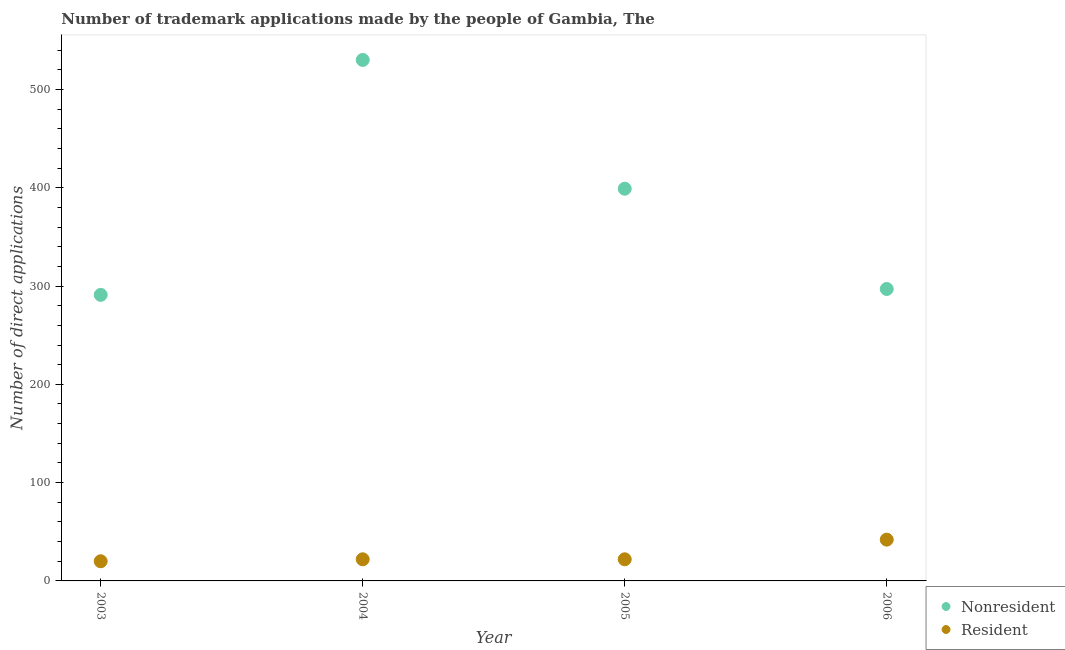How many different coloured dotlines are there?
Keep it short and to the point. 2. Is the number of dotlines equal to the number of legend labels?
Give a very brief answer. Yes. What is the number of trademark applications made by residents in 2006?
Provide a short and direct response. 42. Across all years, what is the maximum number of trademark applications made by non residents?
Give a very brief answer. 530. Across all years, what is the minimum number of trademark applications made by non residents?
Provide a short and direct response. 291. What is the total number of trademark applications made by non residents in the graph?
Offer a very short reply. 1517. What is the difference between the number of trademark applications made by non residents in 2004 and that in 2006?
Your answer should be compact. 233. What is the difference between the number of trademark applications made by residents in 2006 and the number of trademark applications made by non residents in 2004?
Give a very brief answer. -488. What is the average number of trademark applications made by non residents per year?
Give a very brief answer. 379.25. In the year 2004, what is the difference between the number of trademark applications made by non residents and number of trademark applications made by residents?
Your response must be concise. 508. What is the ratio of the number of trademark applications made by non residents in 2003 to that in 2004?
Your answer should be very brief. 0.55. Is the difference between the number of trademark applications made by residents in 2005 and 2006 greater than the difference between the number of trademark applications made by non residents in 2005 and 2006?
Keep it short and to the point. No. What is the difference between the highest and the lowest number of trademark applications made by residents?
Ensure brevity in your answer.  22. Does the number of trademark applications made by residents monotonically increase over the years?
Give a very brief answer. No. How many years are there in the graph?
Give a very brief answer. 4. What is the difference between two consecutive major ticks on the Y-axis?
Provide a succinct answer. 100. Where does the legend appear in the graph?
Provide a succinct answer. Bottom right. How are the legend labels stacked?
Your answer should be very brief. Vertical. What is the title of the graph?
Your response must be concise. Number of trademark applications made by the people of Gambia, The. Does "GDP at market prices" appear as one of the legend labels in the graph?
Your response must be concise. No. What is the label or title of the X-axis?
Your answer should be very brief. Year. What is the label or title of the Y-axis?
Your response must be concise. Number of direct applications. What is the Number of direct applications of Nonresident in 2003?
Your answer should be compact. 291. What is the Number of direct applications of Nonresident in 2004?
Your answer should be very brief. 530. What is the Number of direct applications of Resident in 2004?
Your answer should be compact. 22. What is the Number of direct applications of Nonresident in 2005?
Your response must be concise. 399. What is the Number of direct applications of Resident in 2005?
Offer a terse response. 22. What is the Number of direct applications in Nonresident in 2006?
Offer a terse response. 297. What is the Number of direct applications of Resident in 2006?
Your response must be concise. 42. Across all years, what is the maximum Number of direct applications in Nonresident?
Provide a succinct answer. 530. Across all years, what is the maximum Number of direct applications in Resident?
Ensure brevity in your answer.  42. Across all years, what is the minimum Number of direct applications in Nonresident?
Your response must be concise. 291. What is the total Number of direct applications in Nonresident in the graph?
Keep it short and to the point. 1517. What is the total Number of direct applications in Resident in the graph?
Offer a terse response. 106. What is the difference between the Number of direct applications in Nonresident in 2003 and that in 2004?
Ensure brevity in your answer.  -239. What is the difference between the Number of direct applications of Resident in 2003 and that in 2004?
Make the answer very short. -2. What is the difference between the Number of direct applications in Nonresident in 2003 and that in 2005?
Provide a short and direct response. -108. What is the difference between the Number of direct applications in Resident in 2003 and that in 2005?
Offer a very short reply. -2. What is the difference between the Number of direct applications in Nonresident in 2003 and that in 2006?
Offer a very short reply. -6. What is the difference between the Number of direct applications of Nonresident in 2004 and that in 2005?
Keep it short and to the point. 131. What is the difference between the Number of direct applications of Nonresident in 2004 and that in 2006?
Offer a terse response. 233. What is the difference between the Number of direct applications in Nonresident in 2005 and that in 2006?
Provide a short and direct response. 102. What is the difference between the Number of direct applications in Nonresident in 2003 and the Number of direct applications in Resident in 2004?
Your answer should be very brief. 269. What is the difference between the Number of direct applications in Nonresident in 2003 and the Number of direct applications in Resident in 2005?
Your answer should be very brief. 269. What is the difference between the Number of direct applications in Nonresident in 2003 and the Number of direct applications in Resident in 2006?
Offer a very short reply. 249. What is the difference between the Number of direct applications in Nonresident in 2004 and the Number of direct applications in Resident in 2005?
Give a very brief answer. 508. What is the difference between the Number of direct applications in Nonresident in 2004 and the Number of direct applications in Resident in 2006?
Give a very brief answer. 488. What is the difference between the Number of direct applications of Nonresident in 2005 and the Number of direct applications of Resident in 2006?
Your response must be concise. 357. What is the average Number of direct applications of Nonresident per year?
Your response must be concise. 379.25. In the year 2003, what is the difference between the Number of direct applications in Nonresident and Number of direct applications in Resident?
Offer a very short reply. 271. In the year 2004, what is the difference between the Number of direct applications of Nonresident and Number of direct applications of Resident?
Your answer should be compact. 508. In the year 2005, what is the difference between the Number of direct applications in Nonresident and Number of direct applications in Resident?
Keep it short and to the point. 377. In the year 2006, what is the difference between the Number of direct applications of Nonresident and Number of direct applications of Resident?
Your response must be concise. 255. What is the ratio of the Number of direct applications in Nonresident in 2003 to that in 2004?
Keep it short and to the point. 0.55. What is the ratio of the Number of direct applications in Nonresident in 2003 to that in 2005?
Keep it short and to the point. 0.73. What is the ratio of the Number of direct applications in Nonresident in 2003 to that in 2006?
Make the answer very short. 0.98. What is the ratio of the Number of direct applications of Resident in 2003 to that in 2006?
Your answer should be compact. 0.48. What is the ratio of the Number of direct applications in Nonresident in 2004 to that in 2005?
Give a very brief answer. 1.33. What is the ratio of the Number of direct applications in Nonresident in 2004 to that in 2006?
Provide a succinct answer. 1.78. What is the ratio of the Number of direct applications in Resident in 2004 to that in 2006?
Your response must be concise. 0.52. What is the ratio of the Number of direct applications of Nonresident in 2005 to that in 2006?
Offer a terse response. 1.34. What is the ratio of the Number of direct applications of Resident in 2005 to that in 2006?
Your answer should be very brief. 0.52. What is the difference between the highest and the second highest Number of direct applications in Nonresident?
Your answer should be compact. 131. What is the difference between the highest and the second highest Number of direct applications in Resident?
Keep it short and to the point. 20. What is the difference between the highest and the lowest Number of direct applications of Nonresident?
Provide a short and direct response. 239. What is the difference between the highest and the lowest Number of direct applications of Resident?
Keep it short and to the point. 22. 